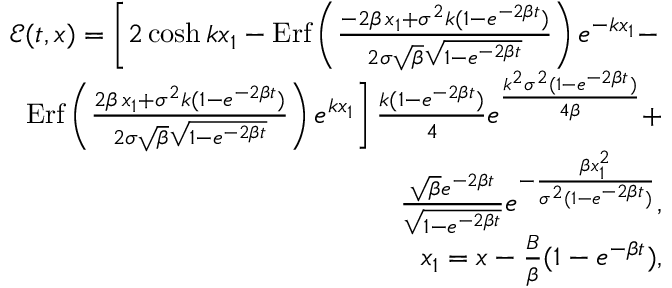<formula> <loc_0><loc_0><loc_500><loc_500>\begin{array} { r l r } & { { \mathcal { E } } ( t , x ) = \left [ 2 \cosh k x _ { 1 } - E r f \left ( \frac { - 2 \beta \, x _ { 1 } + \sigma ^ { 2 } k ( 1 - e ^ { - 2 \beta t } ) } { 2 \sigma \sqrt { \beta } \sqrt { 1 - e ^ { - 2 \beta t } } } \right ) e ^ { - { k x _ { 1 } } } - } \\ & { E r f \left ( \frac { 2 \beta \, x _ { 1 } + \sigma ^ { 2 } k ( 1 - e ^ { - 2 \beta t } ) } { 2 \sigma \sqrt { \beta } \sqrt { 1 - e ^ { - 2 \beta t } } } \right ) e ^ { k x _ { 1 } } \right ] \frac { k ( 1 - e ^ { - 2 \beta t } ) } { 4 } e ^ { \frac { k ^ { 2 } \sigma ^ { 2 } ( 1 - e ^ { - 2 \beta t } ) } { 4 \beta } } + } \\ & { \frac { \sqrt { \beta } e ^ { - 2 \beta t } } { \sqrt { 1 - e ^ { - 2 \beta t } } } e ^ { - \frac { \beta x _ { 1 } ^ { 2 } } { \sigma ^ { 2 } ( 1 - e ^ { - 2 \beta t } ) } } , } \\ & { x _ { 1 } = x - \frac { B } { \beta } ( 1 - e ^ { - \beta t } ) , } \end{array}</formula> 